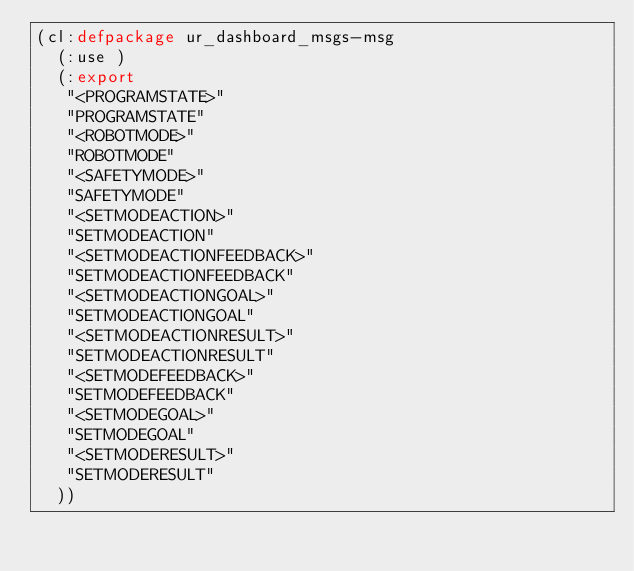<code> <loc_0><loc_0><loc_500><loc_500><_Lisp_>(cl:defpackage ur_dashboard_msgs-msg
  (:use )
  (:export
   "<PROGRAMSTATE>"
   "PROGRAMSTATE"
   "<ROBOTMODE>"
   "ROBOTMODE"
   "<SAFETYMODE>"
   "SAFETYMODE"
   "<SETMODEACTION>"
   "SETMODEACTION"
   "<SETMODEACTIONFEEDBACK>"
   "SETMODEACTIONFEEDBACK"
   "<SETMODEACTIONGOAL>"
   "SETMODEACTIONGOAL"
   "<SETMODEACTIONRESULT>"
   "SETMODEACTIONRESULT"
   "<SETMODEFEEDBACK>"
   "SETMODEFEEDBACK"
   "<SETMODEGOAL>"
   "SETMODEGOAL"
   "<SETMODERESULT>"
   "SETMODERESULT"
  ))

</code> 